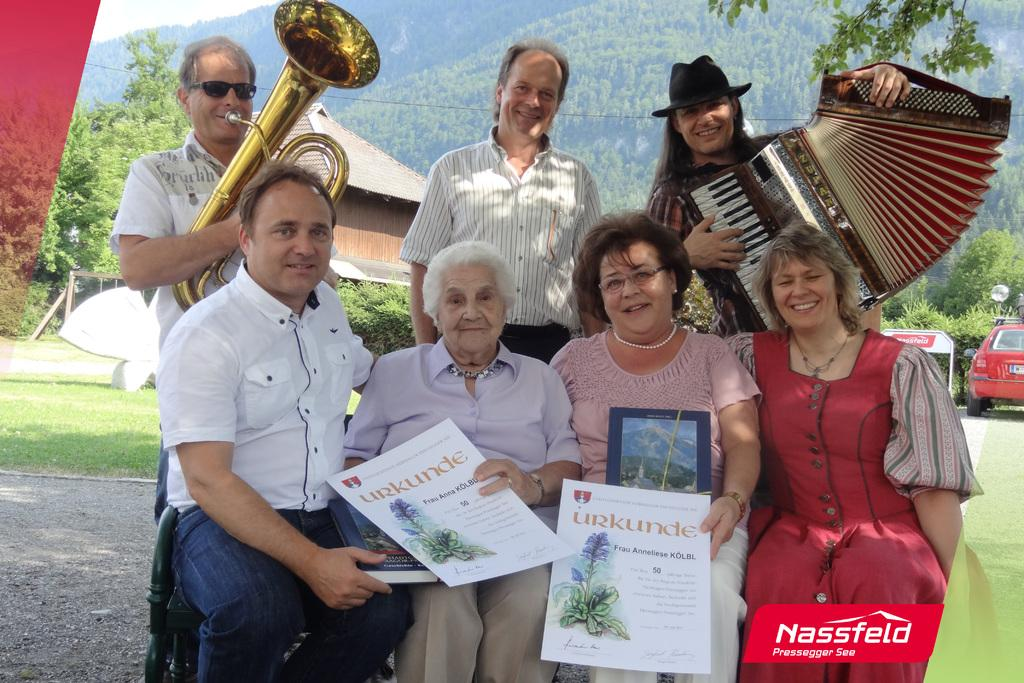<image>
Render a clear and concise summary of the photo. A photograph of some smiling people has a Nassfeld logo in the corner. 